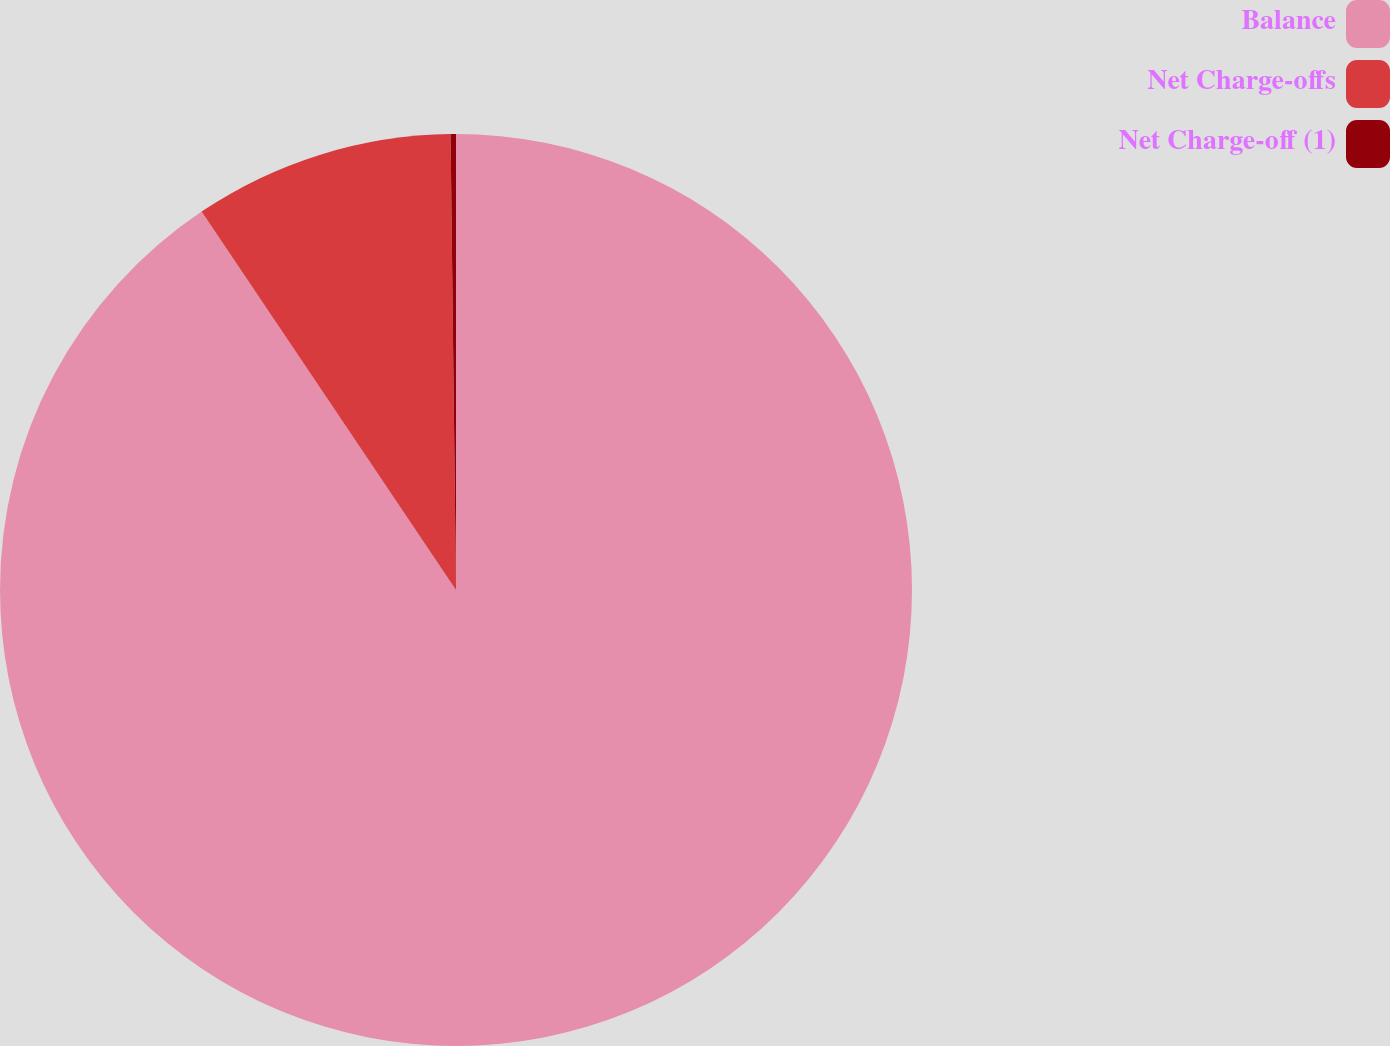Convert chart to OTSL. <chart><loc_0><loc_0><loc_500><loc_500><pie_chart><fcel>Balance<fcel>Net Charge-offs<fcel>Net Charge-off (1)<nl><fcel>90.57%<fcel>9.23%<fcel>0.19%<nl></chart> 